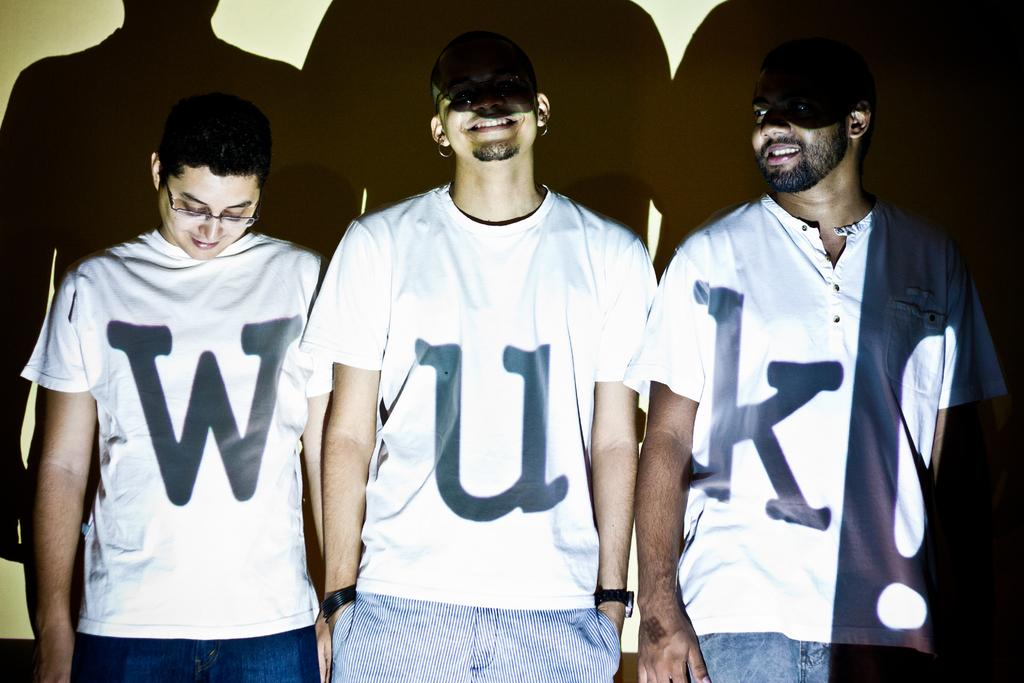Provide a one-sentence caption for the provided image. Three people standing together to spell the name WUK. 